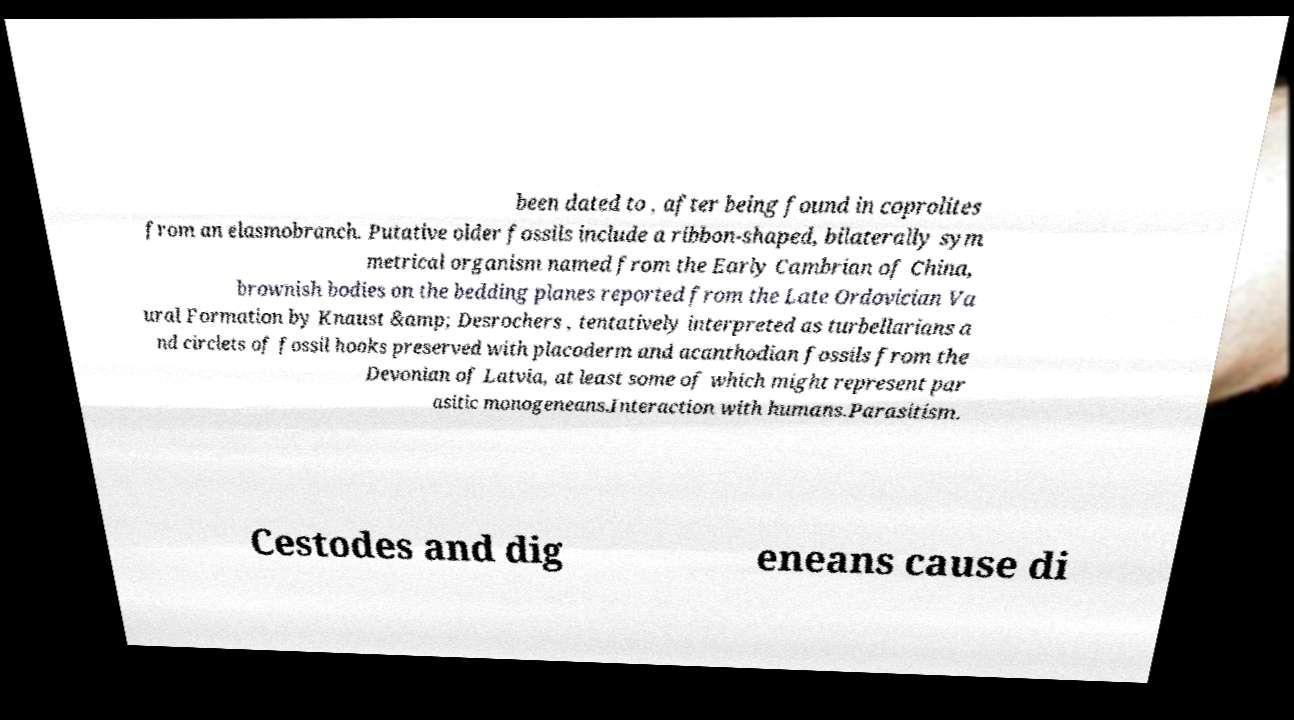Please read and relay the text visible in this image. What does it say? been dated to , after being found in coprolites from an elasmobranch. Putative older fossils include a ribbon-shaped, bilaterally sym metrical organism named from the Early Cambrian of China, brownish bodies on the bedding planes reported from the Late Ordovician Va ural Formation by Knaust &amp; Desrochers , tentatively interpreted as turbellarians a nd circlets of fossil hooks preserved with placoderm and acanthodian fossils from the Devonian of Latvia, at least some of which might represent par asitic monogeneans.Interaction with humans.Parasitism. Cestodes and dig eneans cause di 